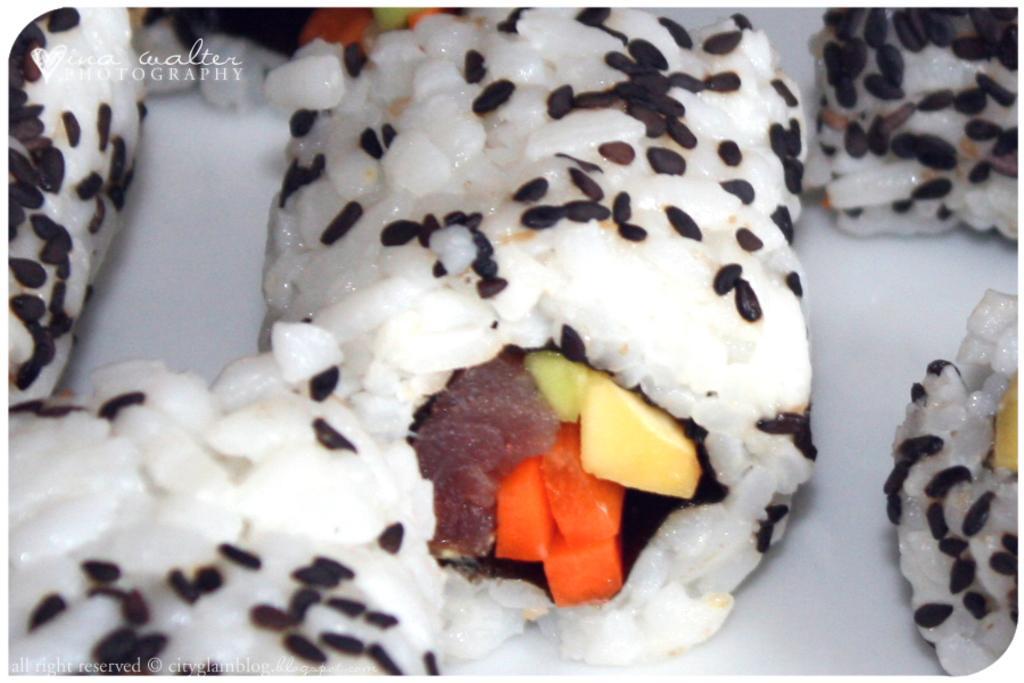Could you give a brief overview of what you see in this image? In this image, we can see a food item on the plate. 